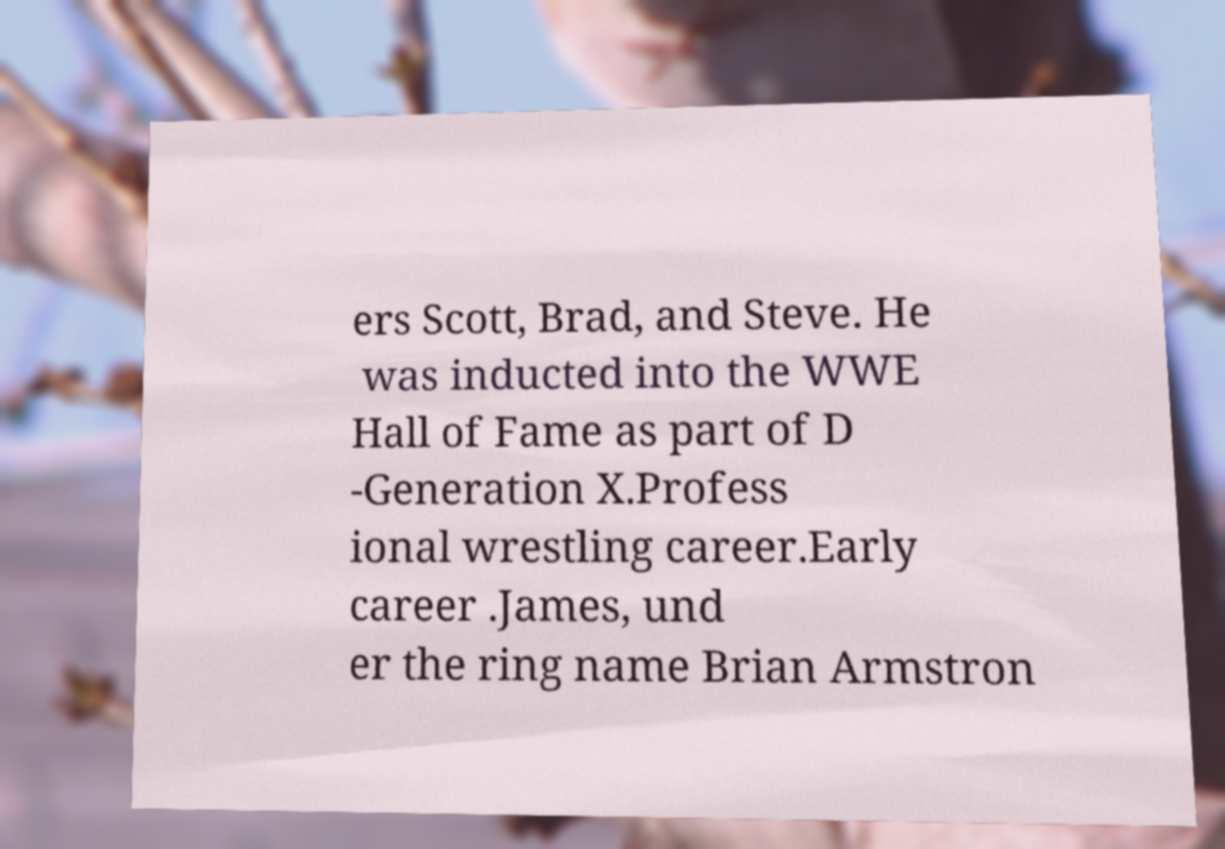Please identify and transcribe the text found in this image. ers Scott, Brad, and Steve. He was inducted into the WWE Hall of Fame as part of D -Generation X.Profess ional wrestling career.Early career .James, und er the ring name Brian Armstron 